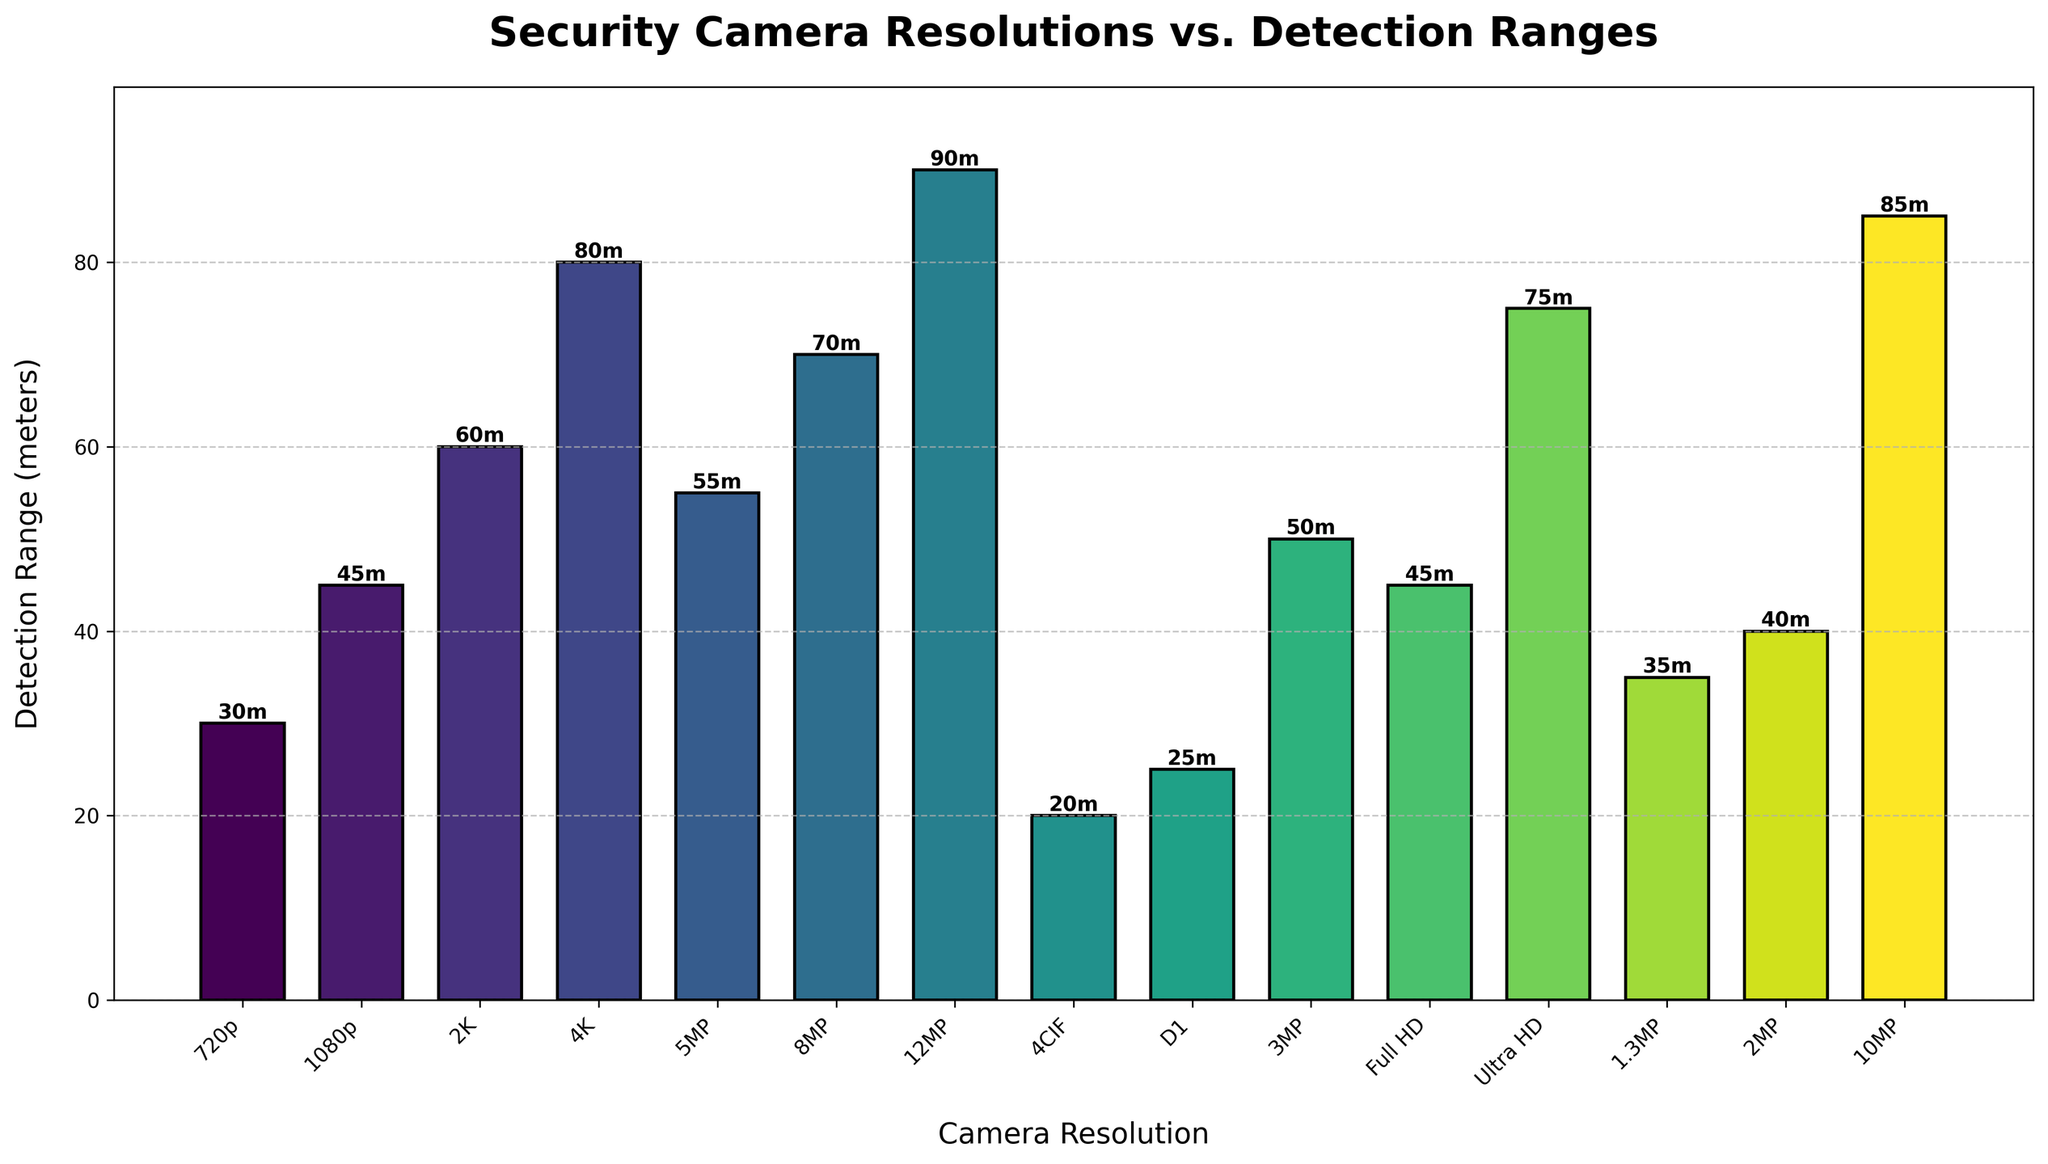What is the resolution with the highest detection range? The bar representing the 12MP resolution is the tallest, indicating it has the highest detection range.
Answer: 12MP Which camera resolution has a detection range of 55 meters? The bar labeled "5MP" has its height corresponding to 55 meters.
Answer: 5MP Compare the detection ranges of the 1080p and 2MP resolutions. The bar representing 1080p is at 45 meters and the bar for 2MP is at 40 meters. Thus, 1080p has a greater detection range.
Answer: 1080p Which bar is taller: Full HD or 4K? Comparing their heights, the bar for 4K is taller, indicating that the detection range of 4K is greater than Full HD.
Answer: 4K What is the total detection range for resolutions 720p, 1080p, and 2K? Adding the values: 30 (720p) + 45 (1080p) + 60 (2K) = 135 meters
Answer: 135 meters Which camera resolution has the shortest detection range? The bar representing 4CIF is the shortest, indicating it has the shortest detection range.
Answer: 4CIF Calculate the average detection range for 3MP, 4K, and Ultra HD resolutions. Adding the values and dividing by 3: (50 + 80 + 75) / 3 = 68.33 meters
Answer: 68.33 meters Is there any resolution with a detection range equal to 35 meters? The bar labeled "1.3MP" has its height corresponding to 35 meters.
Answer: 1.3MP What is the combined detection range of the 8MP and 10MP resolutions? Adding the values: 70 (8MP) + 85 (10MP) = 155 meters
Answer: 155 meters How much greater is the detection range for 12MP compared to D1? Subtracting their values: 90 (12MP) - 25 (D1) = 65 meters
Answer: 65 meters 